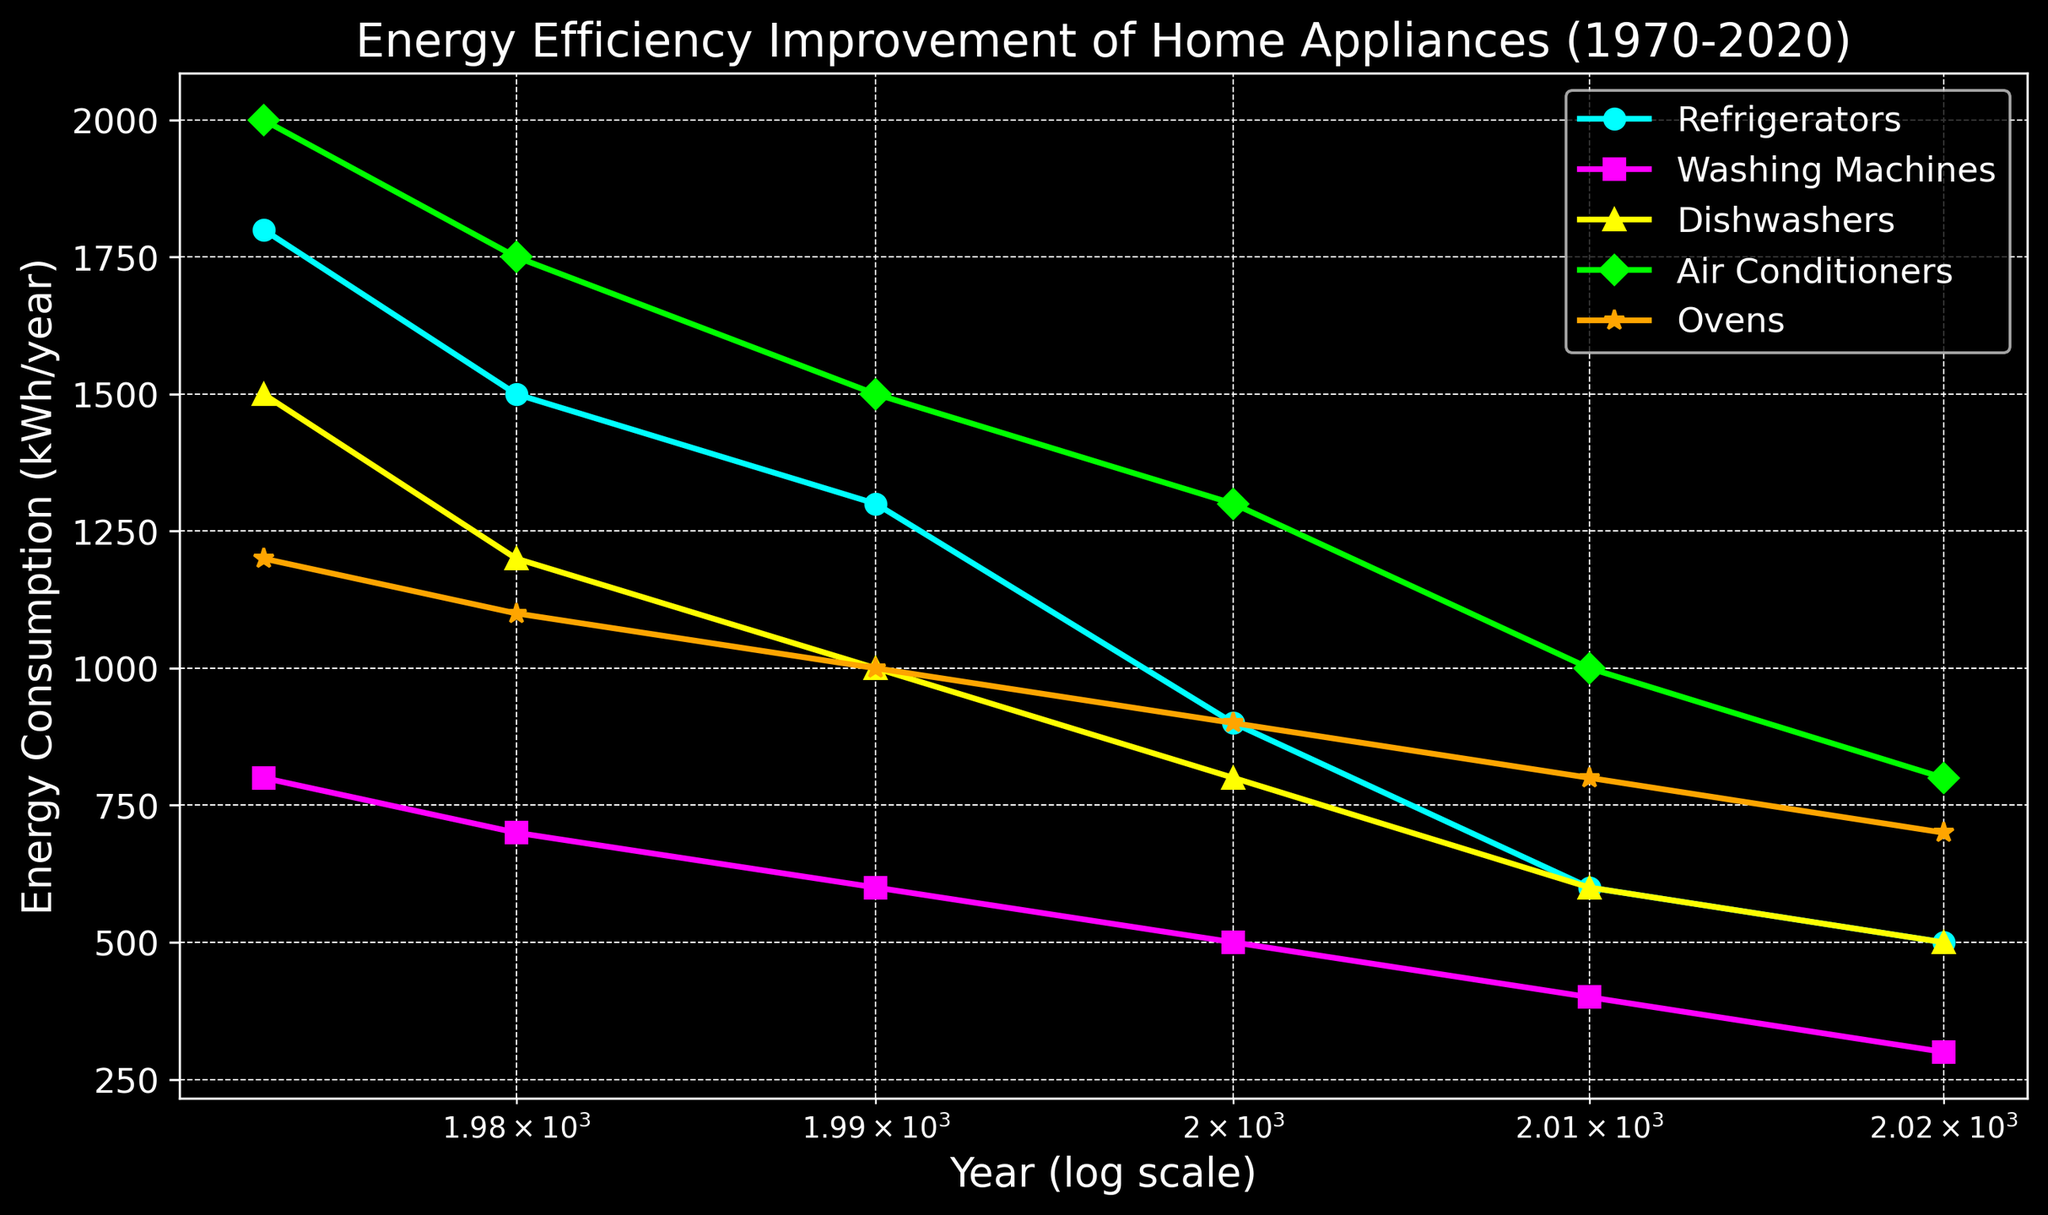What trend can be observed in the energy consumption of refrigerators from 1973 to 2020? The figure shows a consistent downward trend for refrigerators, indicated by the cyan line, from 1800 kWh/year in 1973 to 500 kWh/year in 2020.
Answer: It has decreased Which appliance saw the greatest percentage reduction in energy consumption from 1973 to 2020? To find the greatest percentage reduction, calculate the percentage decrease for each appliance from their 1973 values to their 2020 values. Refrigerators: [(1800-500)/1800]*100 ≈ 72.22%, Washing Machines: [(800-300)/800]*100 ≈ 62.5%, Dishwashers: [(1500-500)/1500]*100 ≈ 66.67%, Air Conditioners: [(2000-800)/2000]*100 = 60%, Ovens: [(1200-700)/1200]*100 ≈ 41.67%. The greatest reduction (refrigerators) is about 72.22%.
Answer: Refrigerators By what year did all the appliances have their energy consumption below 1000 kWh/year? The figure shows that by 2000, the energy consumption for Refrigerators (900 kWh/year), Washing Machines (500 kWh/year), Dishwashers (800 kWh/year), Air Conditioners (1300 kWh/year), and Ovens (900 kWh/year) were all below 1000 kWh/year. For Air Conditioners, it falls below 1000 kWh/year by 2010.
Answer: 2010 Which appliance's energy consumption improved the most between 1980 and 2000? Calculate the absolute reduction for each appliance from 1980 to 2000. Refrigerators: 1500 - 900 = 600, Washing Machines: 700 - 500 = 200, Dishwashers: 1200 - 800 = 400, Air Conditioners: 1750 - 1300 = 450, Ovens: 1100 - 900 = 200. The largest reduction is for Refrigerators with 600 kWh/year.
Answer: Refrigerators What is the average energy consumption of dishwashers over the entire period (1973-2020)? Sum the energy consumption values for dishwashers over the years: 1500 + 1200 + 1000 + 800 + 600 + 500 = 5600 kWh/year. There are 6 data points, so average = 5600/6 ≈ 933.33 kWh/year.
Answer: 933.33 kWh/year In which decade did ovens see the largest reduction in energy consumption? Calculate the reduction for each decade: 1973-1980: 1200 - 1100 = 100, 1980-1990: 1100 - 1000 = 100, 1990-2000: 1000 - 900 = 100, 2000-2010: 900 - 800 = 100, 2010-2020: 800 - 700 = 100. Each decade has a reduction of 100 kWh/year. There's no decade where a larger reduction occurs.
Answer: All equal How does the energy consumption trend for air conditioners compare to that of washing machines? The air conditioners' trend (green line) shows a steady decline from 2000 kWh/year in 1973 to 800 kWh/year in 2020, whereas washing machines (magenta line) show a gradual decrease from 800 kWh/year to 300 kWh/year over the same period. Both trends are downward, but washing machines improve more in relative percentage.
Answer: Both decrease over time 